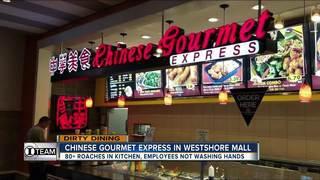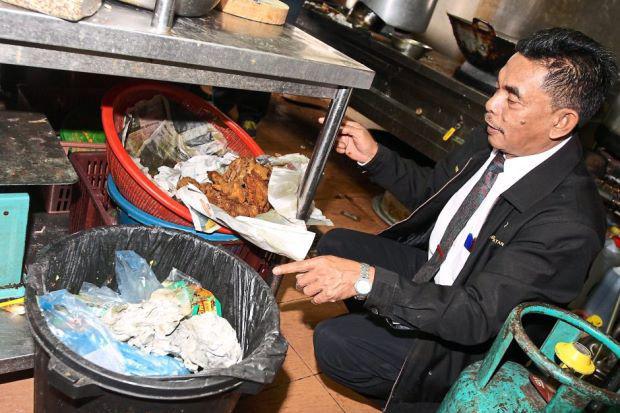The first image is the image on the left, the second image is the image on the right. Given the left and right images, does the statement "Two people are standing in front of a food vendor in the image on the left." hold true? Answer yes or no. No. 